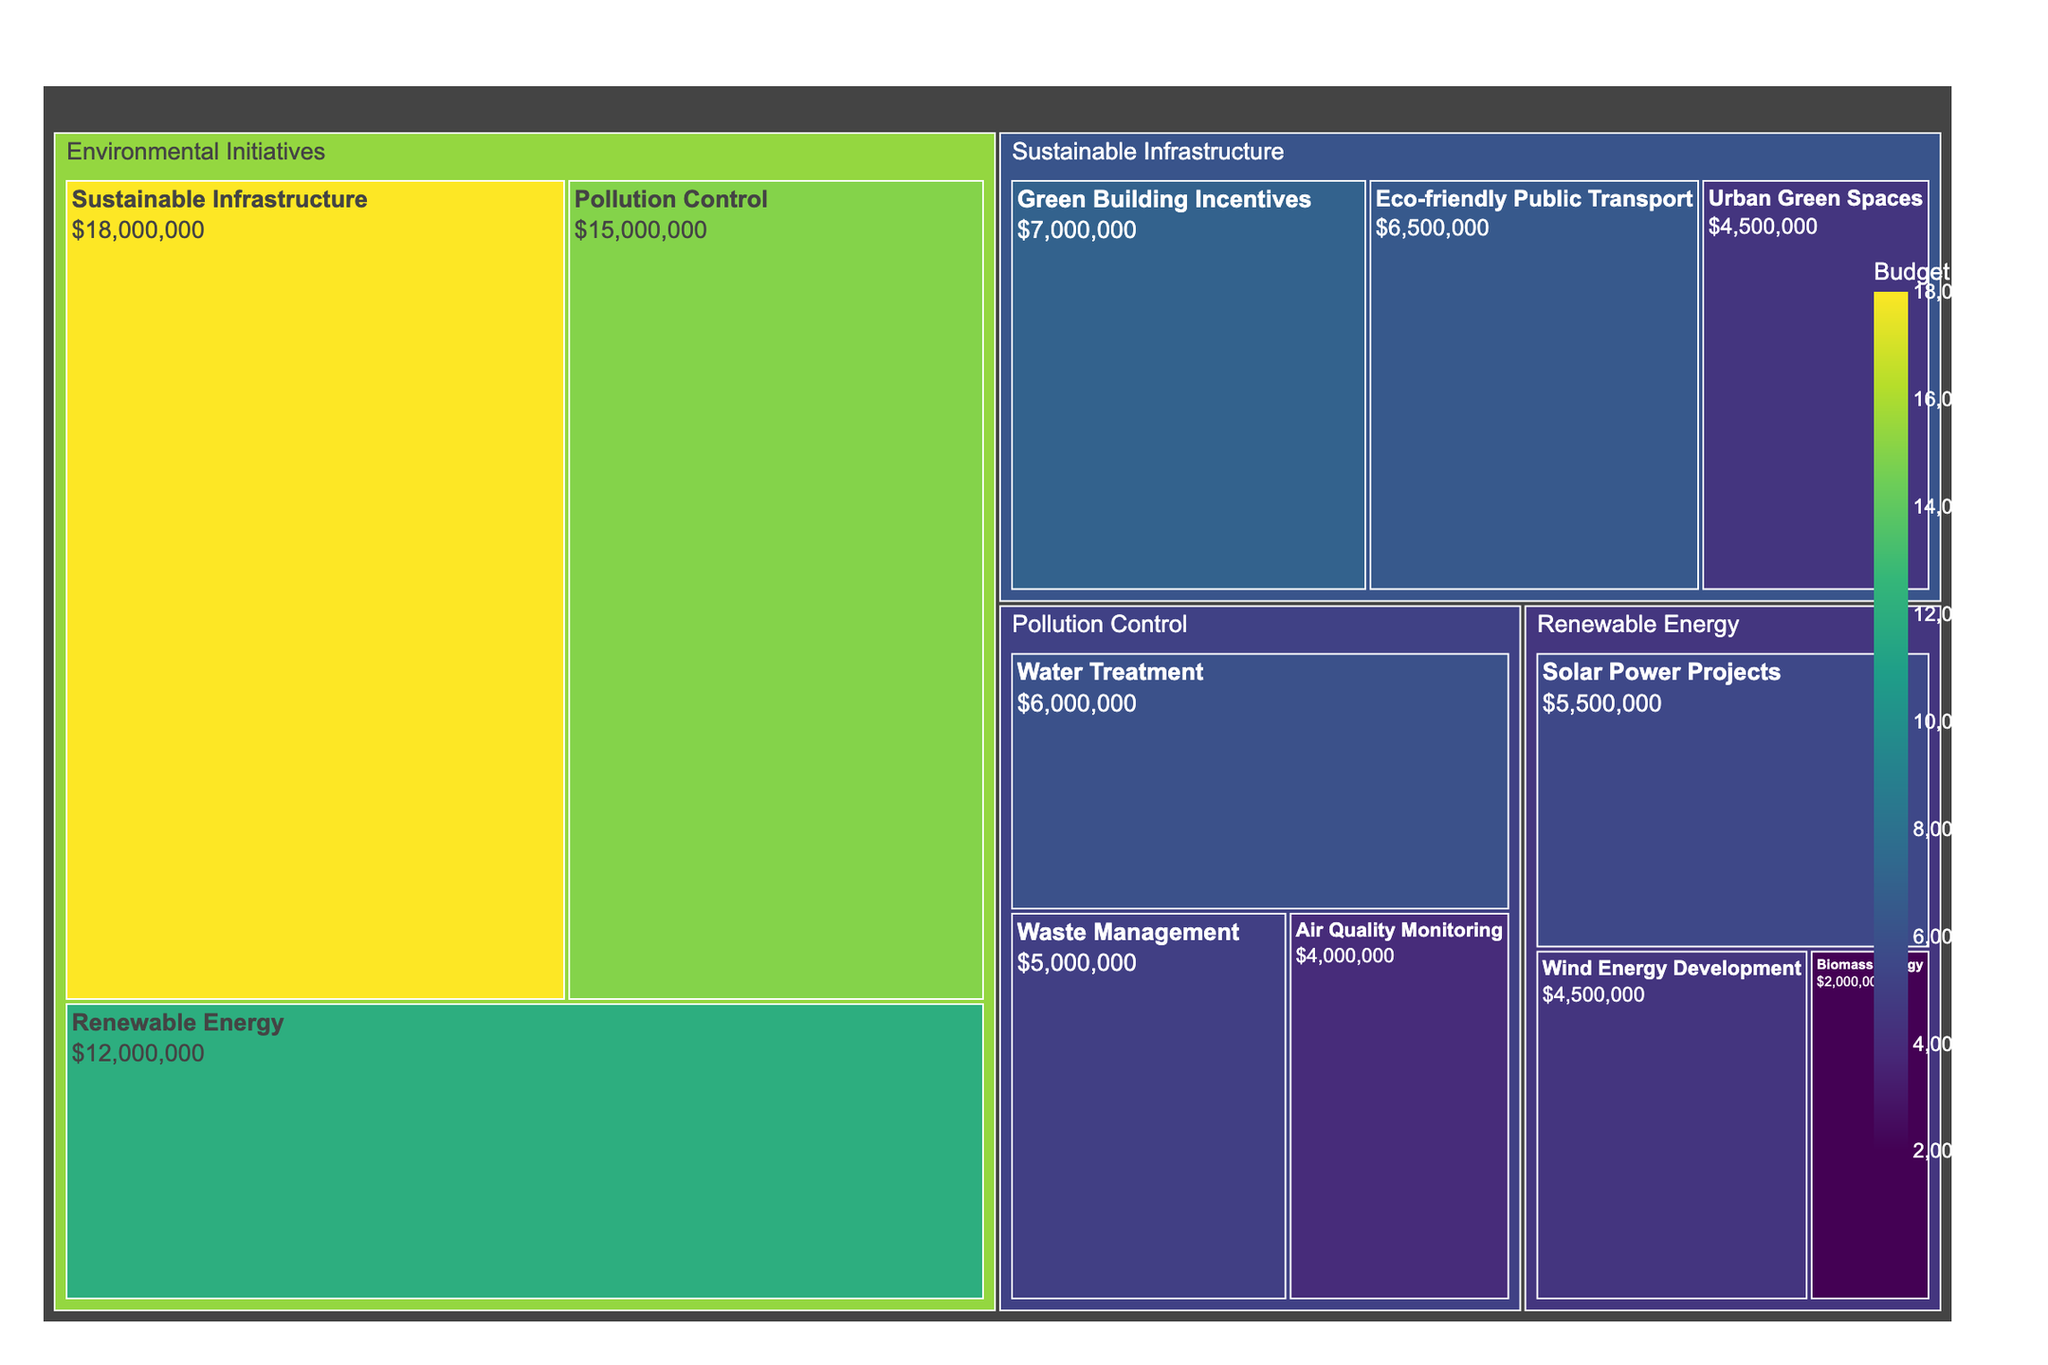What is the title of the figure? The title is usually placed at the top of the figure and serves to indicate the main topic or focus. The title for this treemap is clearly stated.
Answer: City Budget Allocation for Environmental Initiatives Which subcategory under Pollution Control has the highest budget allocation? To find this, look for the largest segment within the Pollution Control category. The subcategory with the highest budget allocation will have the largest area among its peers.
Answer: Water Treatment How much is the total budget allocated to Sustainable Infrastructure initiatives? The total budget for this category is the sum of its subcategories: Green Building Incentives, Eco-friendly Public Transport, and Urban Green Spaces. Sum these values: $7,000,000 + $6,500,000 + $4,500,000.
Answer: $18,000,000 What is the average budget allocation for the subcategories under Renewable Energy? First, find the total budget allocated to Renewable Energy's subcategories: $5,500,000 + $4,500,000 + $2,000,000. Then, divide by the number of subcategories, which is 3.
Answer: $4,000,000 Compare the budget for Air Quality Monitoring and Urban Green Spaces; which one is larger and by how much? Look at the budget allocation for each subcategory and compute the difference: $4,000,000 for Air Quality Monitoring and $4,500,000 for Urban Green Spaces. Subtract the smaller from the larger.
Answer: Urban Green Spaces by $500,000 Which category has the highest overall budget allocation? Compare the total budget allocations of each category: Pollution Control, Renewable Energy, and Sustainable Infrastructure. The category with the highest total allocation will be indicated by the largest area in the treemap.
Answer: Sustainable Infrastructure How does the budget for Solar Power Projects compare to the budget for Green Building Incentives? Determine the budget for each subcategory ($5,500,000 for Solar Power Projects and $7,000,000 for Green Building Incentives) and identify which is larger.
Answer: Green Building Incentives What is the combined budget for Air Quality Monitoring and Waste Management? Add the budget allocations for Air Quality Monitoring ($4,000,000) and Waste Management ($5,000,000).
Answer: $9,000,000 